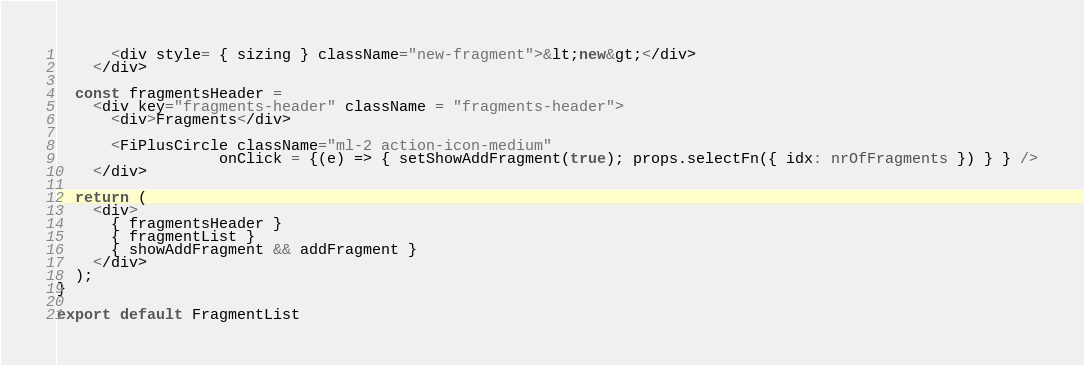<code> <loc_0><loc_0><loc_500><loc_500><_TypeScript_>      <div style= { sizing } className="new-fragment">&lt;new&gt;</div>
    </div>

  const fragmentsHeader =
    <div key="fragments-header" className = "fragments-header">
      <div>Fragments</div>
    
      <FiPlusCircle className="ml-2 action-icon-medium"
                  onClick = {(e) => { setShowAddFragment(true); props.selectFn({ idx: nrOfFragments }) } } />
    </div>

  return (
    <div>
      { fragmentsHeader }
      { fragmentList }
      { showAddFragment && addFragment }
    </div>
  );
}

export default FragmentList
</code> 